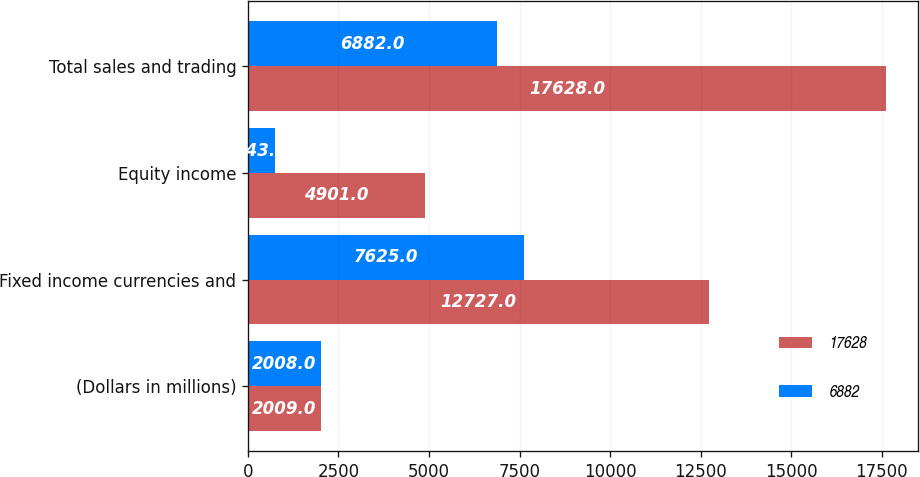Convert chart to OTSL. <chart><loc_0><loc_0><loc_500><loc_500><stacked_bar_chart><ecel><fcel>(Dollars in millions)<fcel>Fixed income currencies and<fcel>Equity income<fcel>Total sales and trading<nl><fcel>17628<fcel>2009<fcel>12727<fcel>4901<fcel>17628<nl><fcel>6882<fcel>2008<fcel>7625<fcel>743<fcel>6882<nl></chart> 